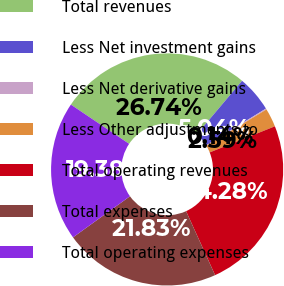<chart> <loc_0><loc_0><loc_500><loc_500><pie_chart><fcel>Total revenues<fcel>Less Net investment gains<fcel>Less Net derivative gains<fcel>Less Other adjustments to<fcel>Total operating revenues<fcel>Total expenses<fcel>Total operating expenses<nl><fcel>26.74%<fcel>5.04%<fcel>0.14%<fcel>2.59%<fcel>24.28%<fcel>21.83%<fcel>19.38%<nl></chart> 